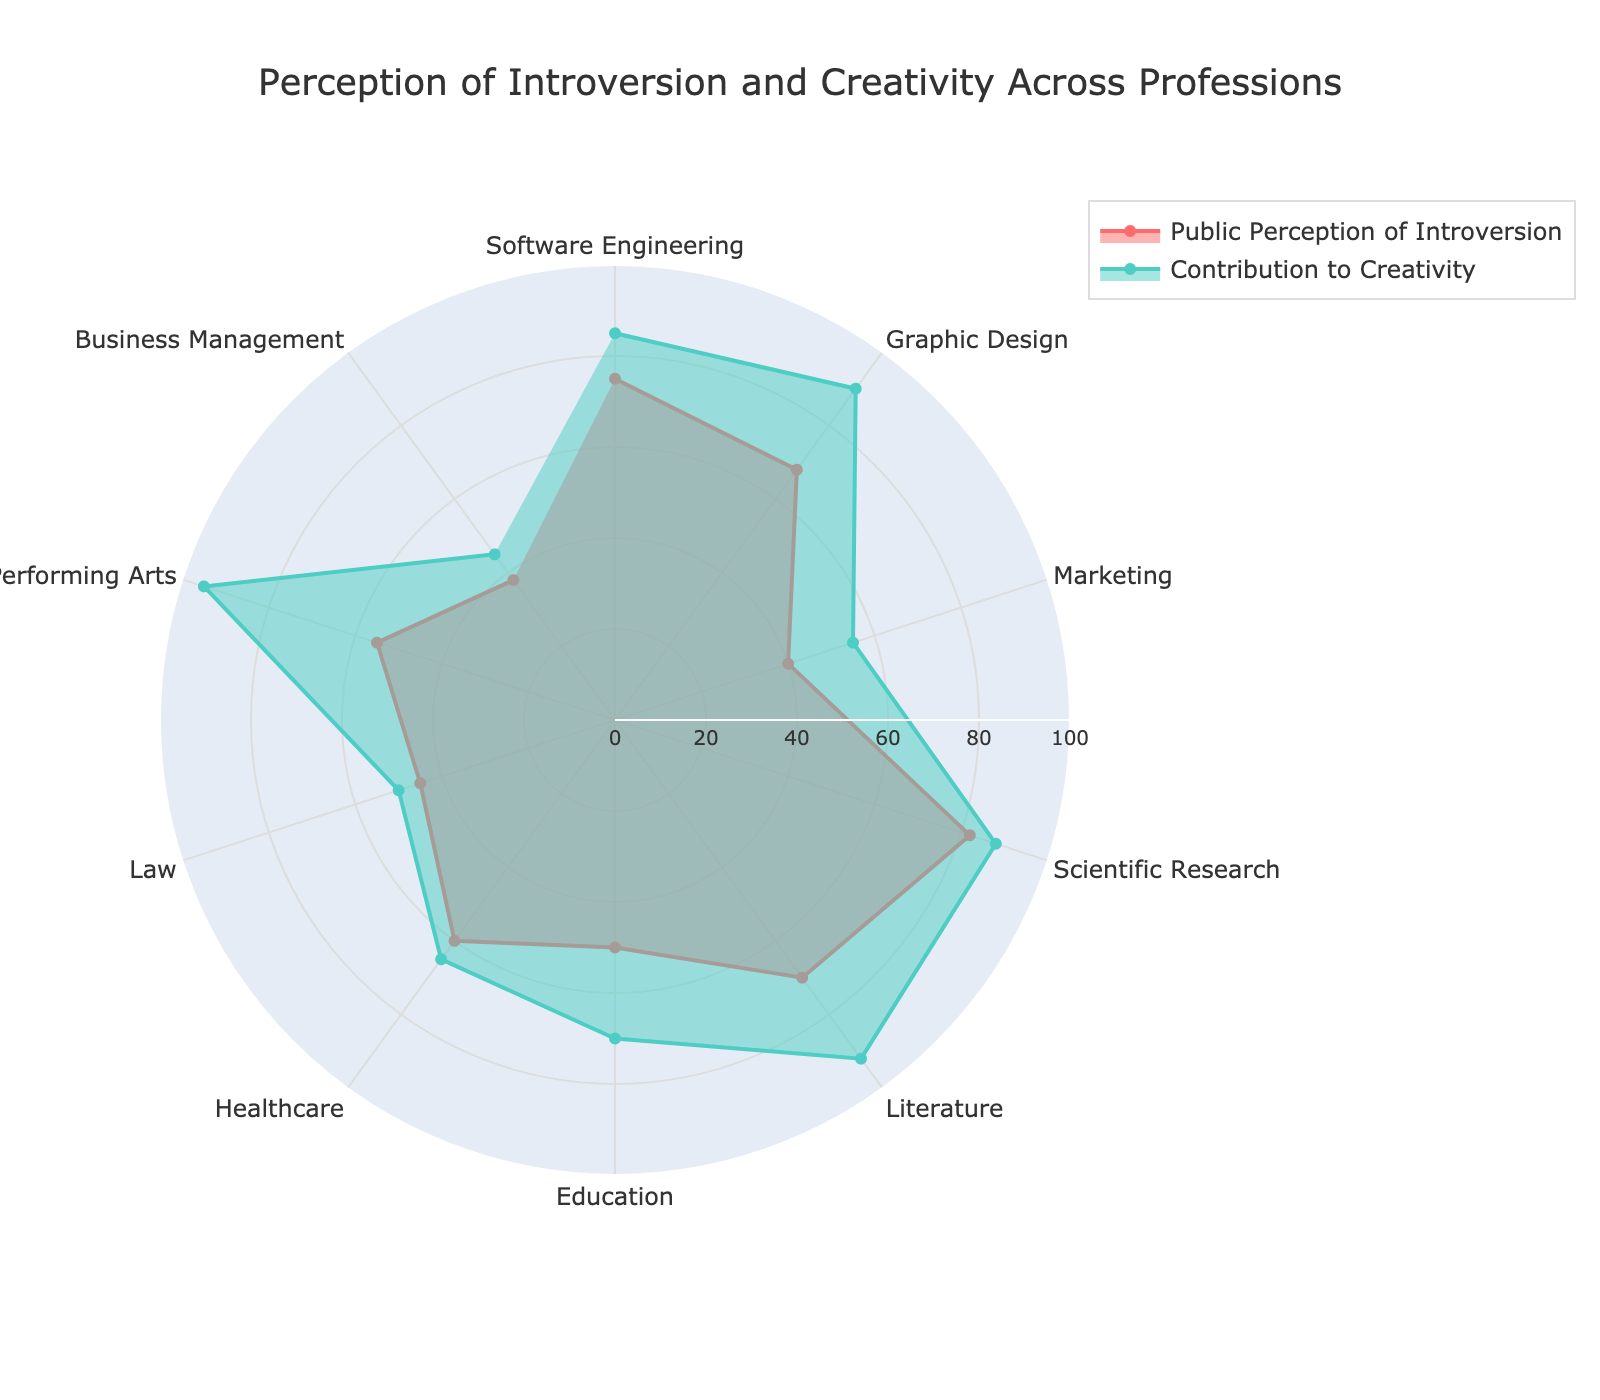Which profession has the highest public perception of introversion? By examining the radar chart and identifying the profession with the highest 'Public Perception of Introversion' value, we can observe that 'Scientific Research' has the highest score.
Answer: Scientific Research Which profession is perceived as the least introverted? By examining the radar chart for the lowest value on 'Public Perception of Introversion', we see that 'Business Management' has the lowest score.
Answer: Business Management Among the professions listed, which one has the highest contribution to creativity? By examining the radar chart for the highest 'Contribution to Creativity' value, 'Performing Arts' stands out as the one with the highest score.
Answer: Performing Arts Which profession shows the largest difference between public perception of introversion and their contribution to creativity? To find this, calculate the difference between 'Public Perception of Introversion' and 'Contribution to Creativity' for each profession and identify the maximum. 'Performing Arts' shows the largest difference (95 - 55 = 40).
Answer: Performing Arts Are there any professions where the public perception of introversion and contribution to creativity are equal? By examining the radar chart and comparing the values of 'Public Perception of Introversion' and 'Contribution to Creativity' for each profession, we find no professions where these two values are equal.
Answer: No Which profession has a higher public perception of introversion: Software Engineering or Graphic Design? By examining the radar chart, we find that 'Software Engineering' has a higher 'Public Perception of Introversion' (75) compared to 'Graphic Design' (68).
Answer: Software Engineering What is the average public perception of introversion across all professions? Sum all the values of 'Public Perception of Introversion' and divide by the number of professions: (75 + 68 + 40 + 82 + 70 + 50 + 60 + 45 + 55 + 38) / 10 = 58.3
Answer: 58.3 Which profession has the smallest difference between public perception of introversion and contribution to creativity? Calculate the absolute differences for each profession and identify the minimum: 'Healthcare' shows the smallest difference (65 - 60 = 5).
Answer: Healthcare Is there a positive correlation between public perception of introversion and contribution to creativity in the chart? By examining the general trend in the radar chart, professions with high public perception of introversion, such as 'Scientific Research' and 'Literature', also tend to have high contributions to creativity, suggesting a positive correlation.
Answer: Yes 